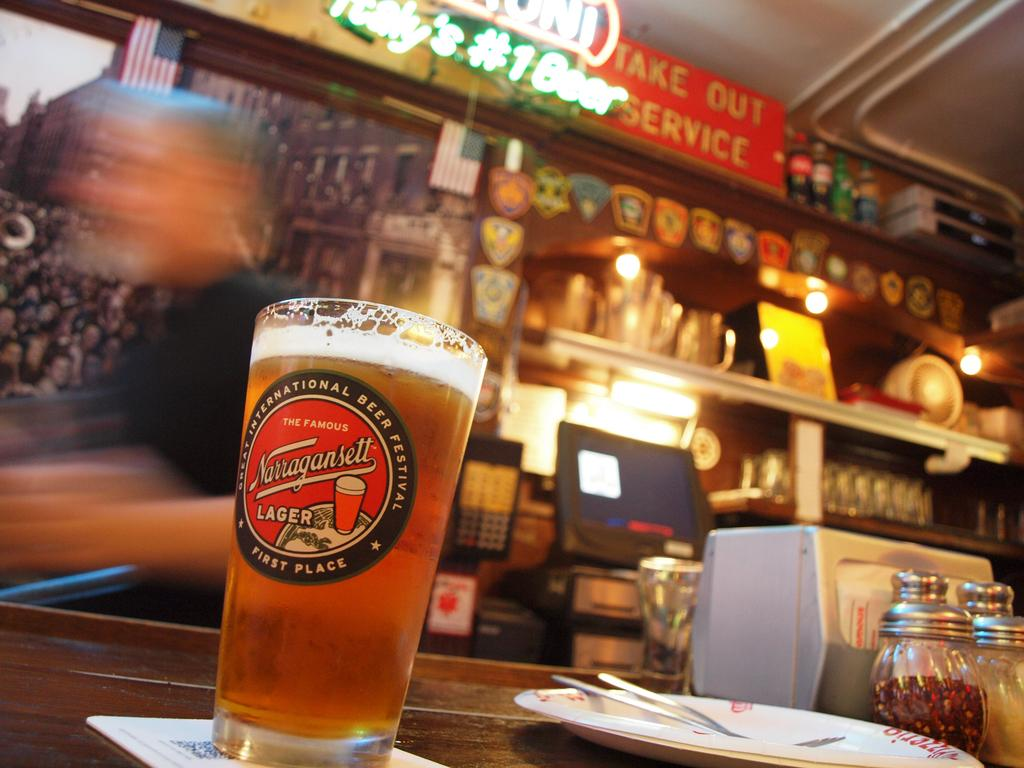<image>
Render a clear and concise summary of the photo. A bar that offers people take out service. 